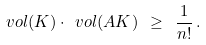<formula> <loc_0><loc_0><loc_500><loc_500>\ v o l ( K ) \cdot \ v o l ( A K ) \ \geq \ \frac { 1 } { n ! } \, .</formula> 